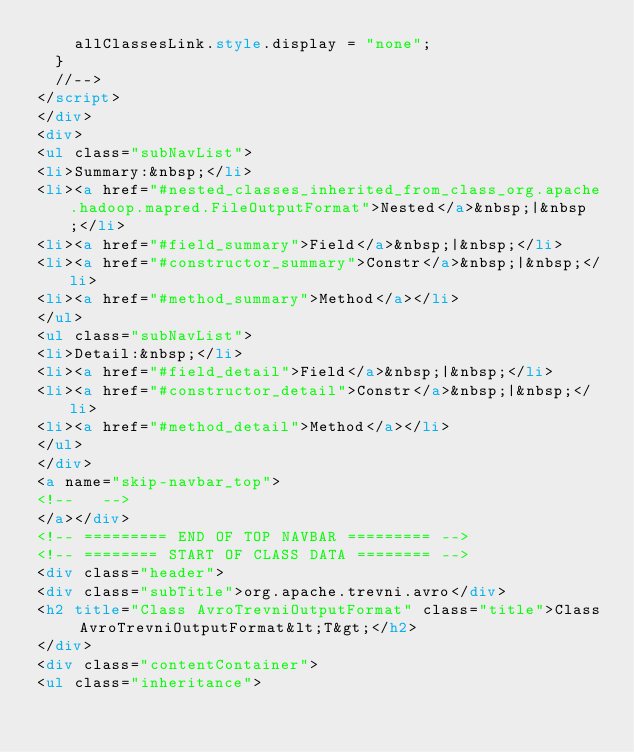Convert code to text. <code><loc_0><loc_0><loc_500><loc_500><_HTML_>    allClassesLink.style.display = "none";
  }
  //-->
</script>
</div>
<div>
<ul class="subNavList">
<li>Summary:&nbsp;</li>
<li><a href="#nested_classes_inherited_from_class_org.apache.hadoop.mapred.FileOutputFormat">Nested</a>&nbsp;|&nbsp;</li>
<li><a href="#field_summary">Field</a>&nbsp;|&nbsp;</li>
<li><a href="#constructor_summary">Constr</a>&nbsp;|&nbsp;</li>
<li><a href="#method_summary">Method</a></li>
</ul>
<ul class="subNavList">
<li>Detail:&nbsp;</li>
<li><a href="#field_detail">Field</a>&nbsp;|&nbsp;</li>
<li><a href="#constructor_detail">Constr</a>&nbsp;|&nbsp;</li>
<li><a href="#method_detail">Method</a></li>
</ul>
</div>
<a name="skip-navbar_top">
<!--   -->
</a></div>
<!-- ========= END OF TOP NAVBAR ========= -->
<!-- ======== START OF CLASS DATA ======== -->
<div class="header">
<div class="subTitle">org.apache.trevni.avro</div>
<h2 title="Class AvroTrevniOutputFormat" class="title">Class AvroTrevniOutputFormat&lt;T&gt;</h2>
</div>
<div class="contentContainer">
<ul class="inheritance"></code> 